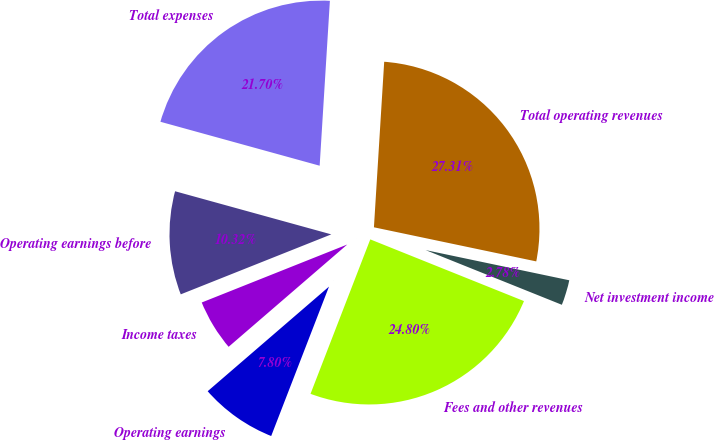Convert chart. <chart><loc_0><loc_0><loc_500><loc_500><pie_chart><fcel>Fees and other revenues<fcel>Net investment income<fcel>Total operating revenues<fcel>Total expenses<fcel>Operating earnings before<fcel>Income taxes<fcel>Operating earnings<nl><fcel>24.8%<fcel>2.78%<fcel>27.31%<fcel>21.7%<fcel>10.32%<fcel>5.29%<fcel>7.8%<nl></chart> 